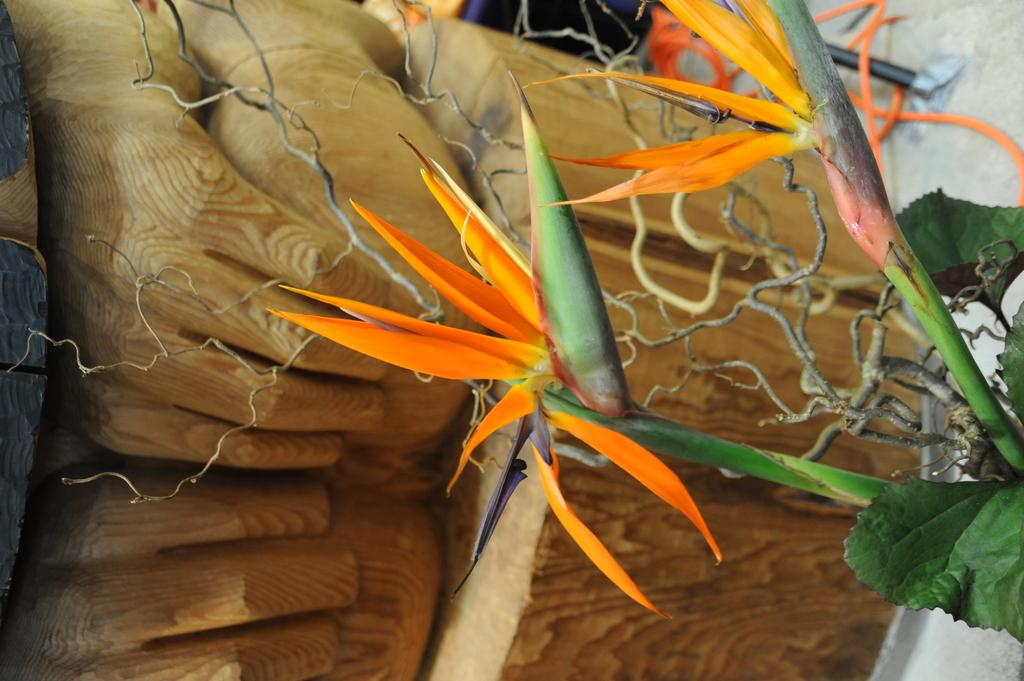What is the main subject in the center of the image? There is a plant in the center of the image. What can be seen in the background of the image? There is a wooden statue in the background. What is the wooden statue placed on? The wooden statue is on a wooden structure. Are there any other objects visible in the background? Yes, there are a few other objects visible in the background. How many eggs are on the shelf in the image? There is no shelf or eggs present in the image. What type of battle is depicted in the image? There is no battle or any indication of conflict in the image. 